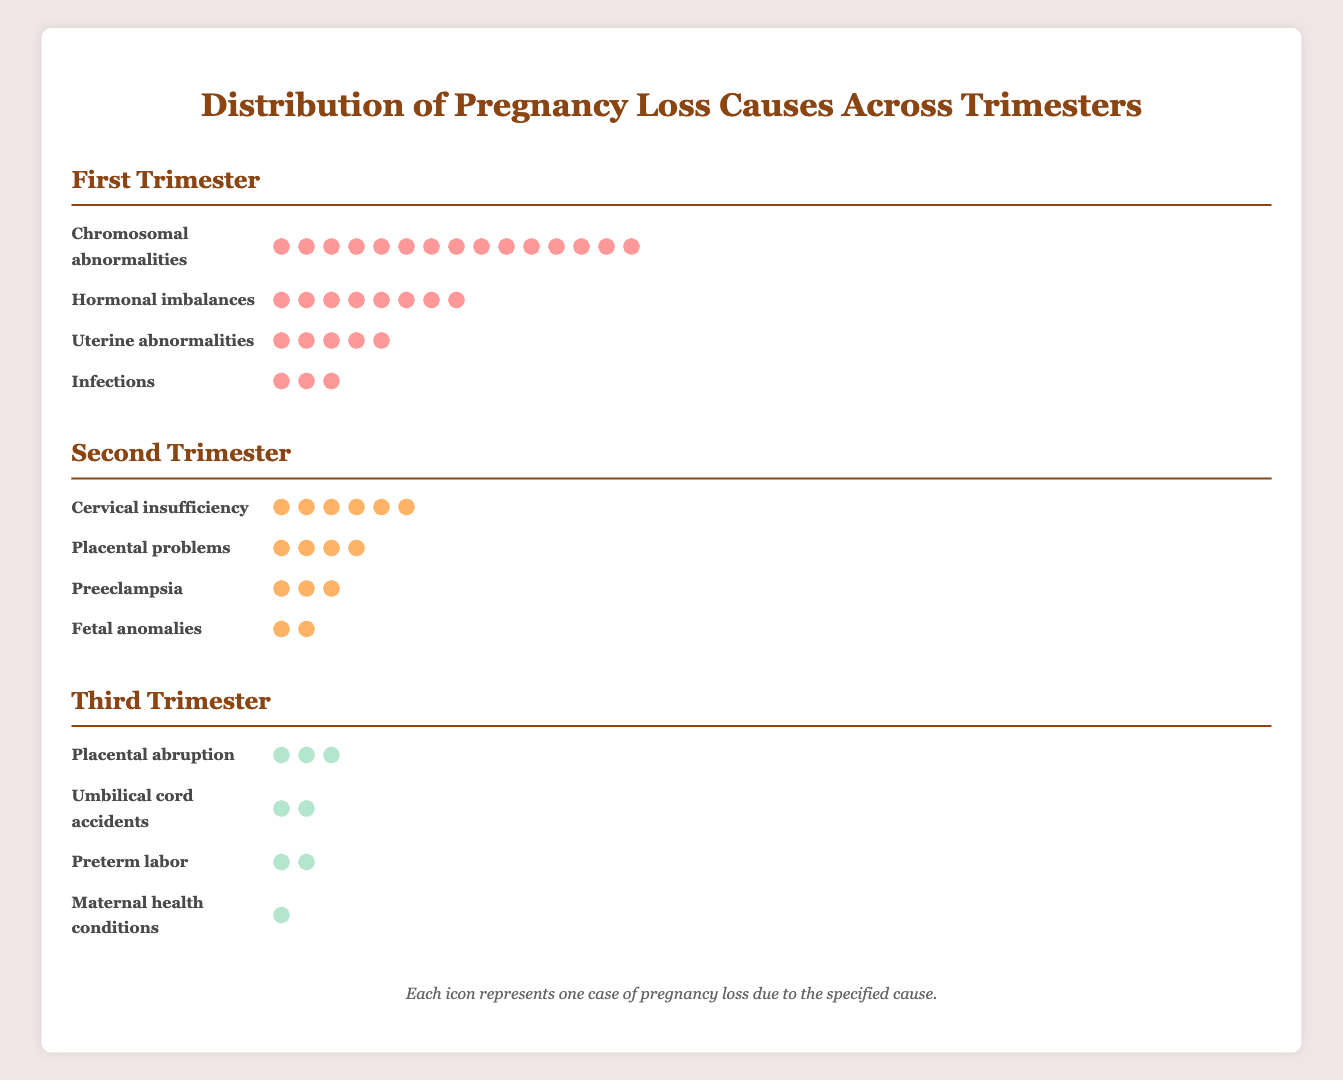How many causes of pregnancy loss are detailed for the Second Trimester? By looking at the "Second Trimester" section in the plot, we can count the number of causes listed: Cervical insufficiency, Placental problems, Preeclampsia, and Fetal anomalies. There are four causes detailed.
Answer: Four Which cause of pregnancy loss has the highest count in the First Trimester? In the "First Trimester" section, the number of icons next to "Chromosomal abnormalities" is the highest at 15.
Answer: Chromosomal abnormalities What is the total number of pregnancy loss cases depicted for the Third Trimester? Adding up all the cases listed under the "Third Trimester" section: Placental abruption (3), Umbilical cord accidents (2), Preterm labor (2), and Maternal health conditions (1), the total is 3 + 2 + 2 + 1 = 8.
Answer: Eight Compare the number of cases due to "Hormonal imbalances" in the First Trimester and "Cervical insufficiency" in the Second Trimester. Which is greater? "Hormonal imbalances" in the First Trimester has 8 counts represented by icons, while "Cervical insufficiency" in the Second Trimester has 6 counts. 8 is greater than 6.
Answer: Hormonal imbalances What is the second most common cause of pregnancy loss in the First Trimester? The second most common cause in the "First Trimester" section is "Hormonal imbalances" with 8 icons, just behind "Chromosomal abnormalities".
Answer: Hormonal imbalances How many total pregnancy loss cases are due to infections and placental problems across all trimesters? In the "First Trimester," infections have 3 cases. In the "Second Trimester," placental problems have 4 cases. Summing these yields 3 + 4 = 7.
Answer: Seven Is there any cause of pregnancy loss that appears in more than one trimester? By checking all the causes listed under each trimester, no cause appears in more than one trimester section in the plot.
Answer: No How do the counts of causes in the Second Trimester compare to the counts in the First Trimester? Summing the counts for the Second Trimester: 6 (Cervical insufficiency) + 4 (Placental problems) + 3 (Preeclampsia) + 2 (Fetal anomalies) = 15. For the First Trimester: 15 (Chromosomal abnormalities) + 8 (Hormonal imbalances) + 5 (Uterine abnormalities) + 3 (Infections) = 31. The First Trimester has more cases.
Answer: First Trimester has more Which trimester has the fewest total pregnancy loss cases and how many? Adding the counts: First Trimester (31), Second Trimester (15), Third Trimester (8). The Third Trimester has the fewest with 8 cases.
Answer: Third Trimester with 8 What is the most common cause of pregnancy loss in the Third Trimester? The cause with the highest count in the "Third Trimester" section is "Placental abruption" with 3 icons.
Answer: Placental abruption 